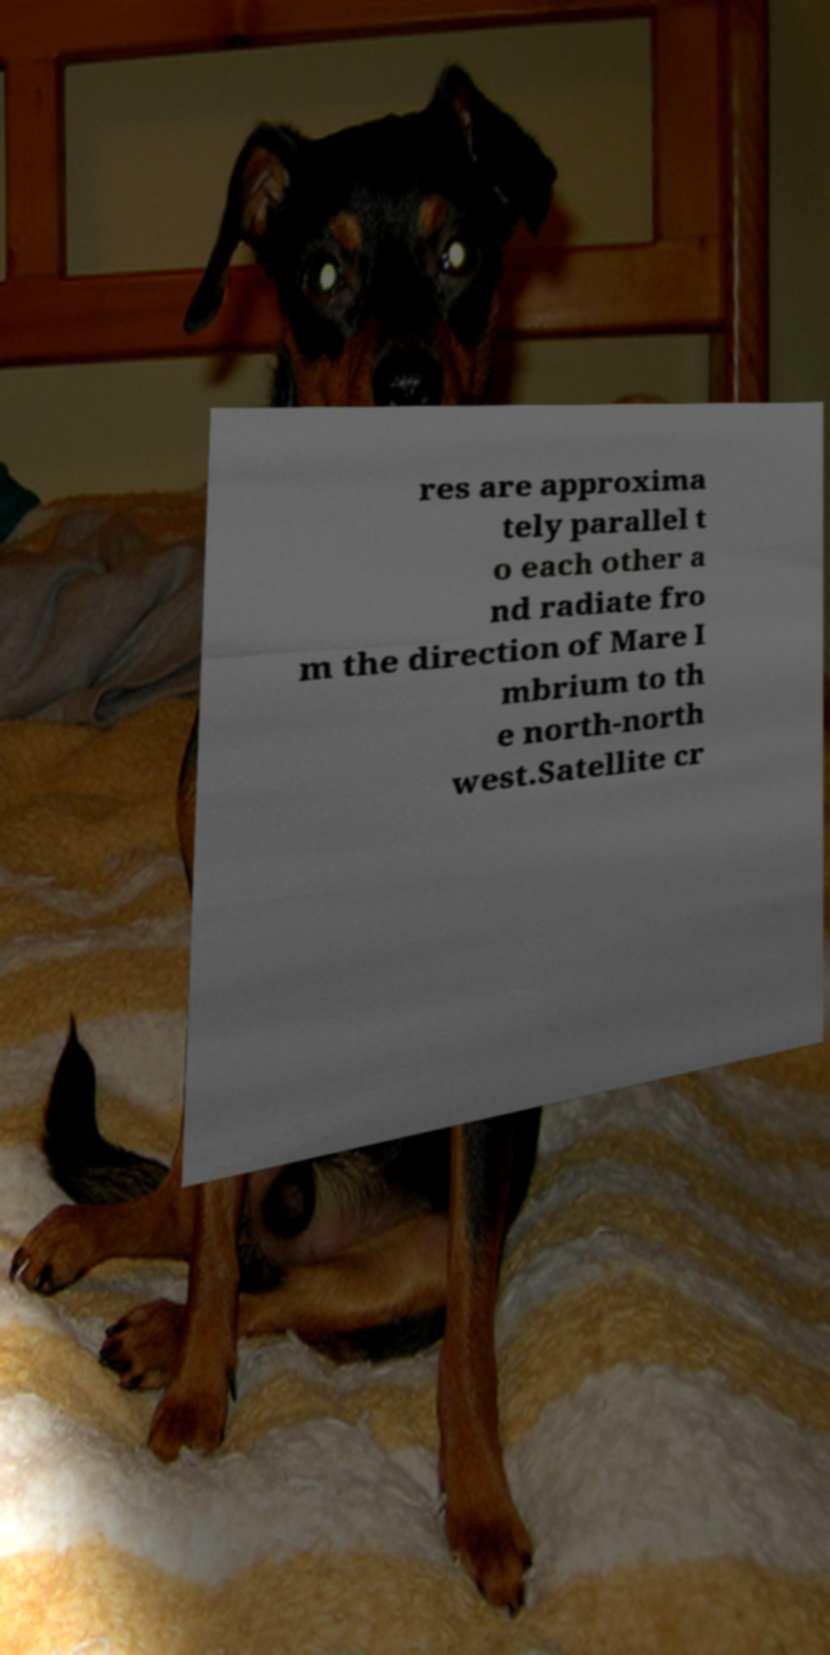Can you read and provide the text displayed in the image?This photo seems to have some interesting text. Can you extract and type it out for me? res are approxima tely parallel t o each other a nd radiate fro m the direction of Mare I mbrium to th e north-north west.Satellite cr 